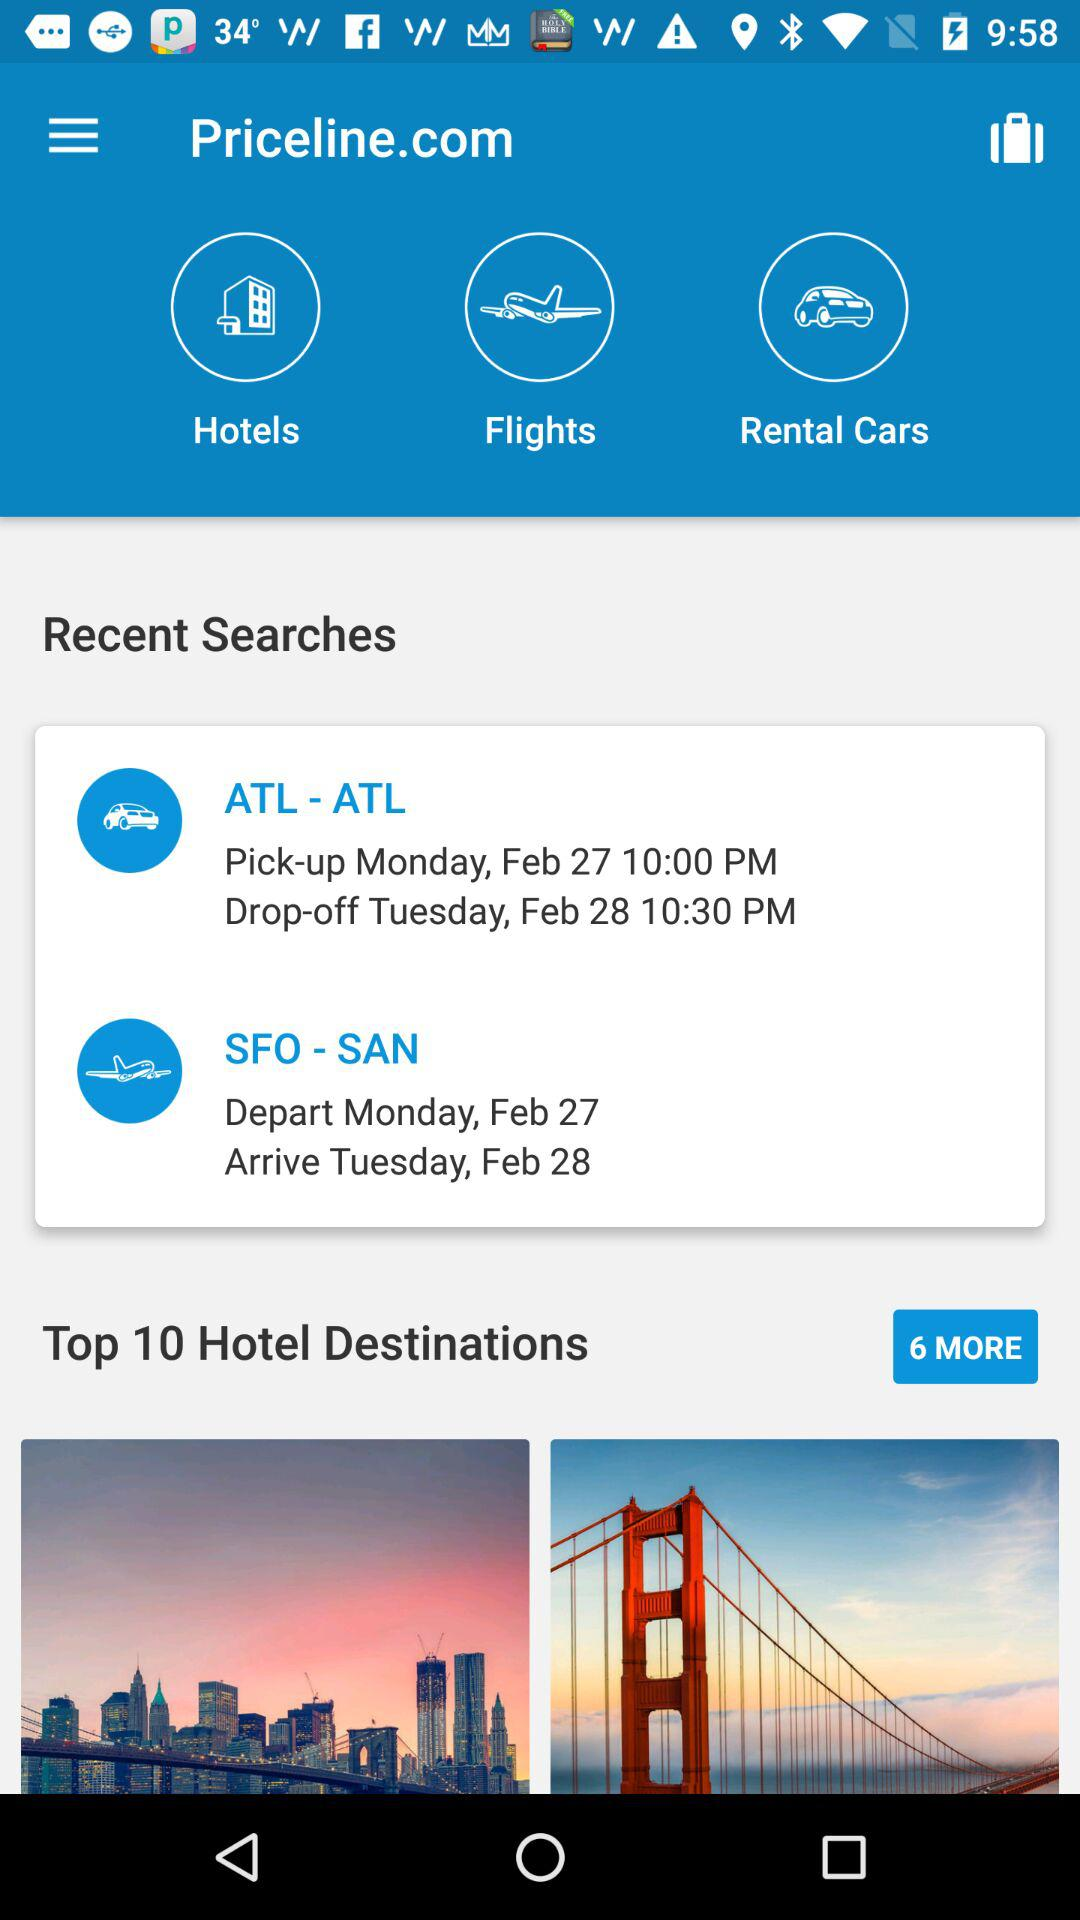How many hotels are there on the list for the top hotel destinations? There are 10 hotels. 